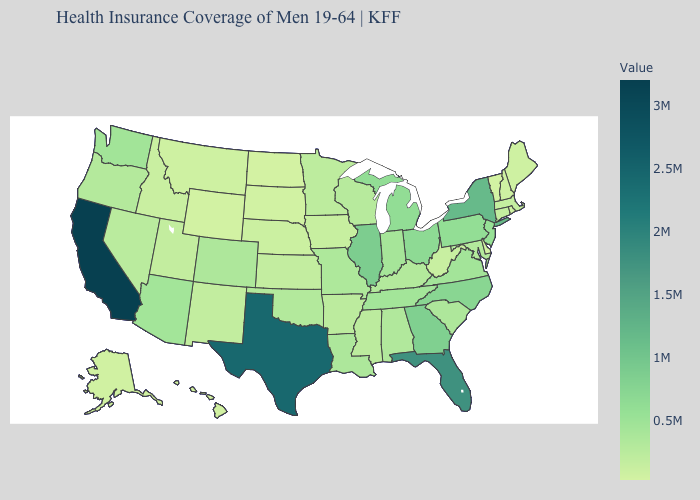Does New Mexico have the highest value in the West?
Concise answer only. No. Which states have the lowest value in the USA?
Concise answer only. Vermont. Does Vermont have the lowest value in the USA?
Answer briefly. Yes. Which states hav the highest value in the South?
Short answer required. Texas. Among the states that border Kentucky , does West Virginia have the lowest value?
Quick response, please. Yes. 